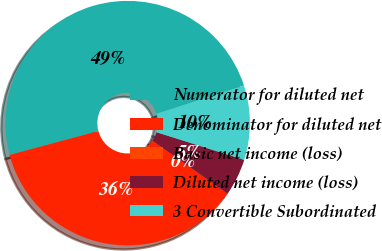<chart> <loc_0><loc_0><loc_500><loc_500><pie_chart><fcel>Numerator for diluted net<fcel>Denominator for diluted net<fcel>Basic net income (loss)<fcel>Diluted net income (loss)<fcel>3 Convertible Subordinated<nl><fcel>49.2%<fcel>36.04%<fcel>0.0%<fcel>4.92%<fcel>9.84%<nl></chart> 